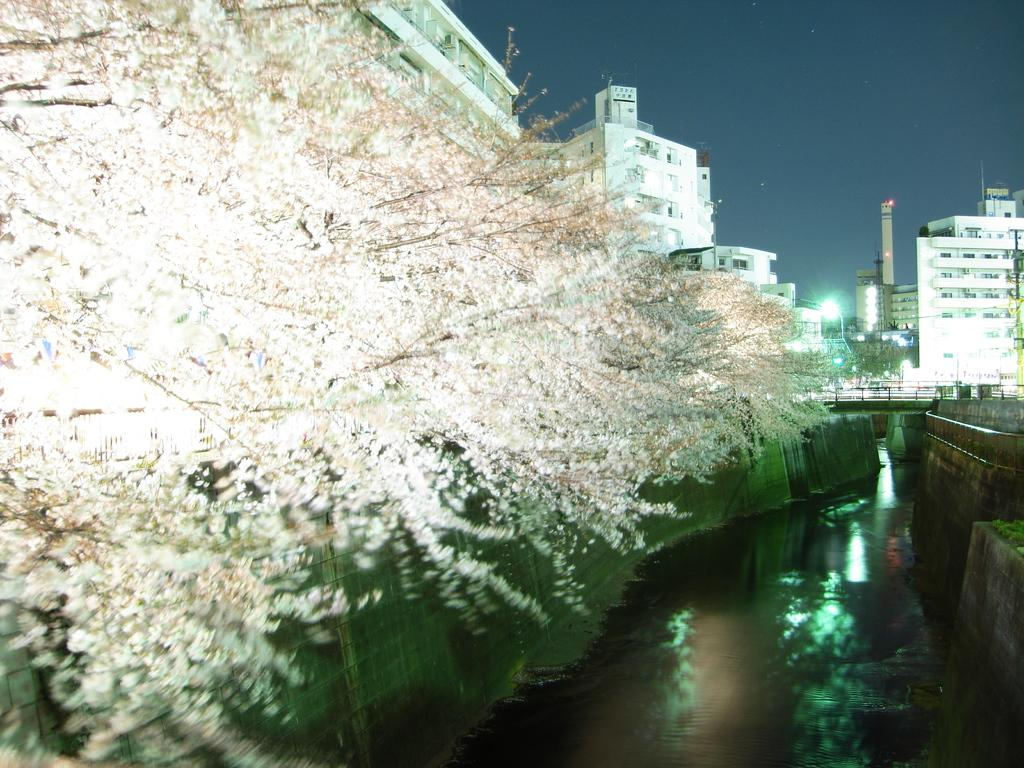What type of structures can be seen in the image? There are buildings in the image. What else is visible in the image besides the buildings? There are lights, a bridge, and fencing in the image. Are there any natural elements present in the image? Yes, there are white color flowers on the trees. What is the color of the sky in the image? The sky is blue in the image. How many cows can be seen in the image? There are no cows present in the image. What message of hope can be found in the image? The image does not contain any text or symbols that convey a message of hope. 